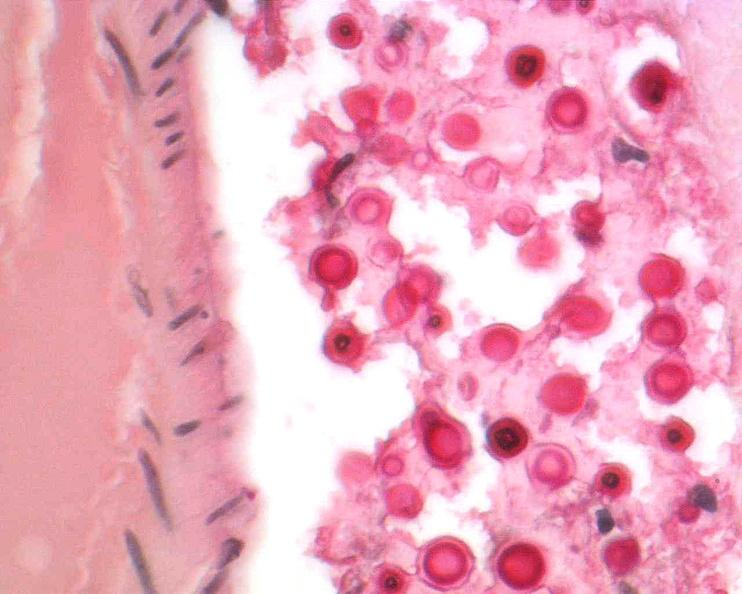do spleen stain?
Answer the question using a single word or phrase. No 